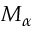<formula> <loc_0><loc_0><loc_500><loc_500>M _ { \alpha }</formula> 